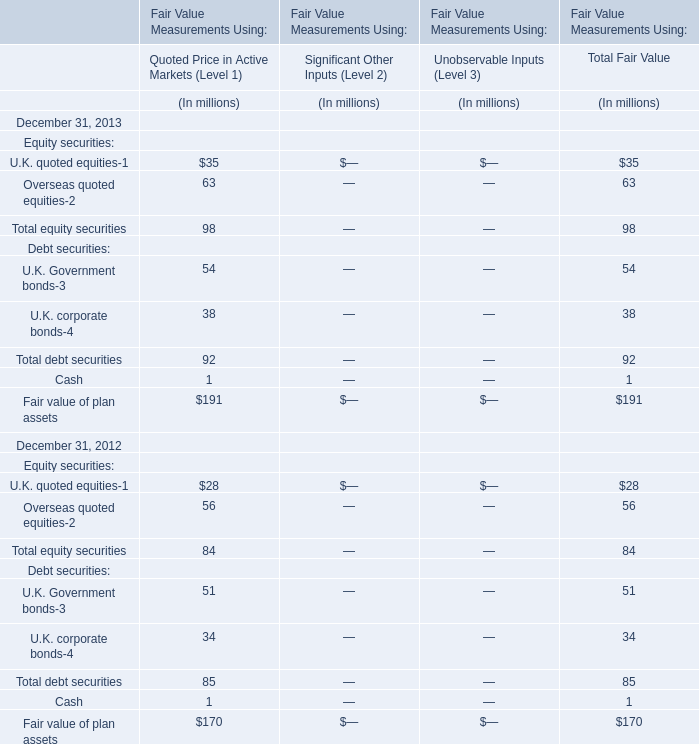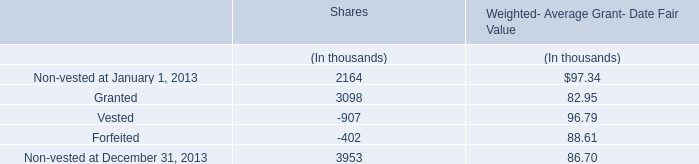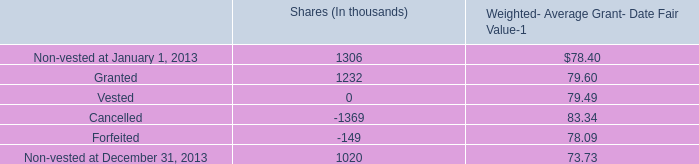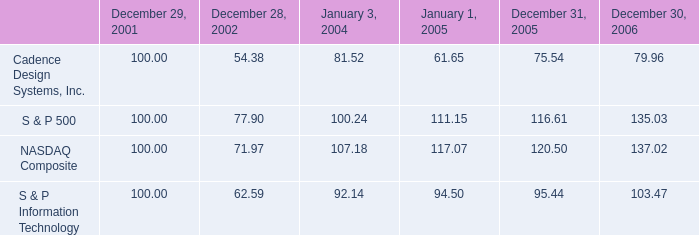What is the sum of Granted for Shares in Table 2 and Granted for Weighted- Average Grant- Date Fair Value in Table 1? (in thousand) 
Computations: (1232 + 82.95)
Answer: 1314.95. 